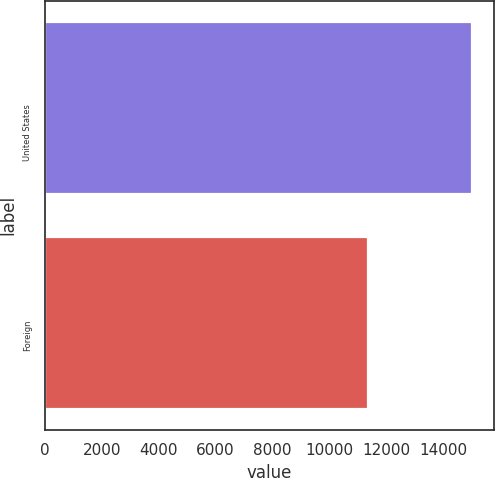Convert chart to OTSL. <chart><loc_0><loc_0><loc_500><loc_500><bar_chart><fcel>United States<fcel>Foreign<nl><fcel>15029<fcel>11367<nl></chart> 